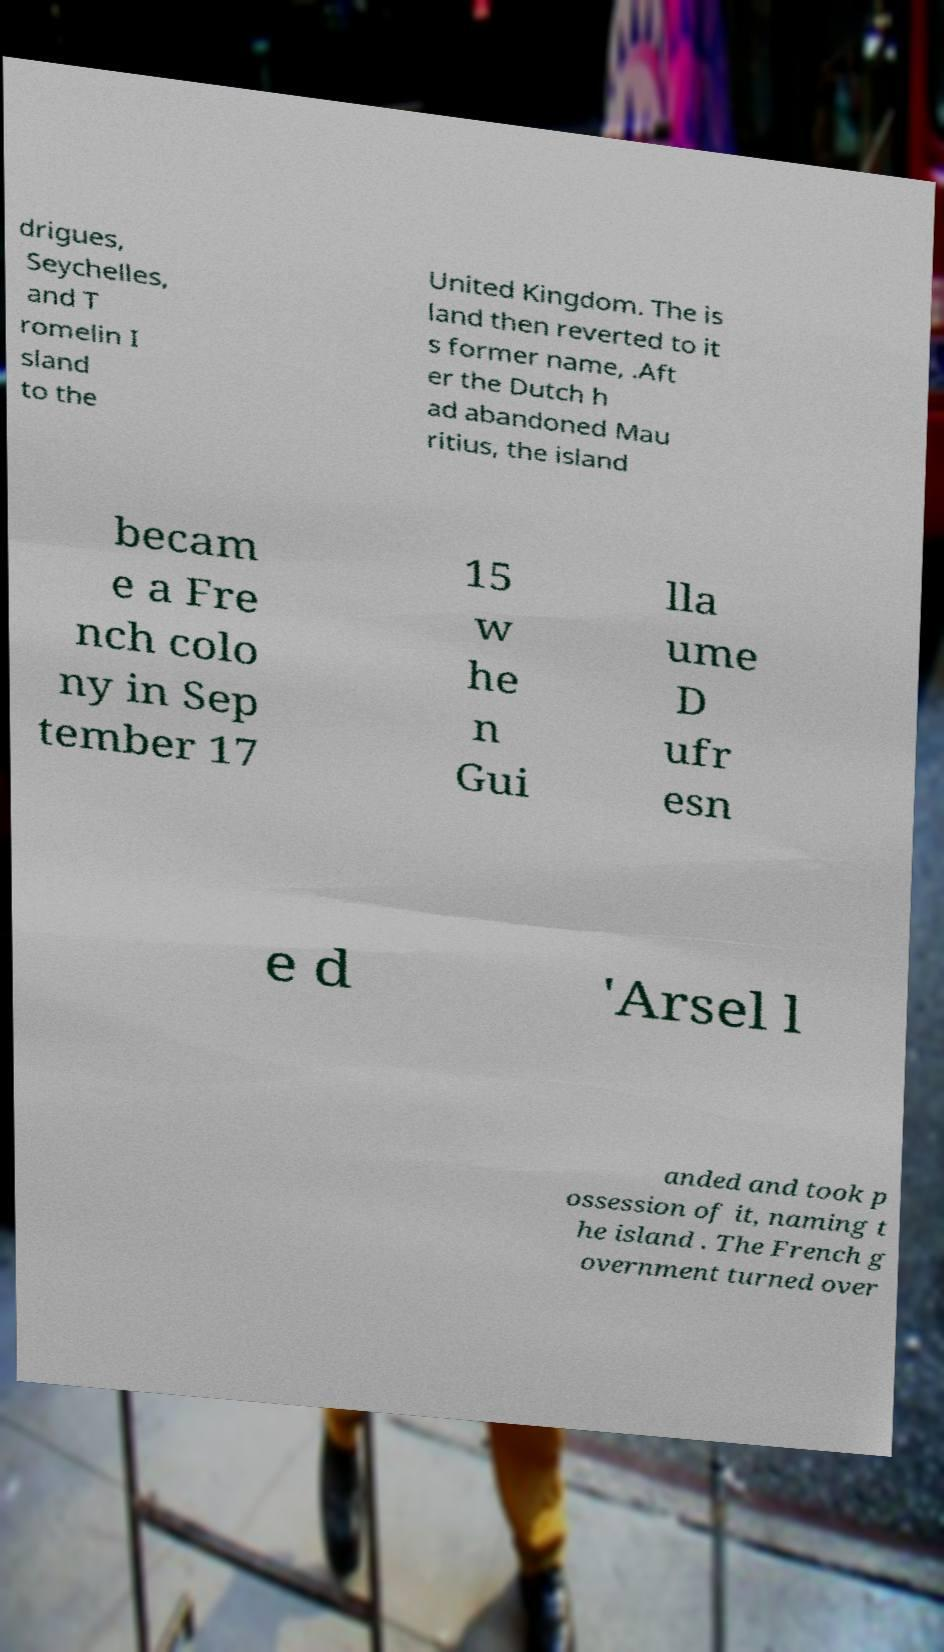I need the written content from this picture converted into text. Can you do that? drigues, Seychelles, and T romelin I sland to the United Kingdom. The is land then reverted to it s former name, .Aft er the Dutch h ad abandoned Mau ritius, the island becam e a Fre nch colo ny in Sep tember 17 15 w he n Gui lla ume D ufr esn e d 'Arsel l anded and took p ossession of it, naming t he island . The French g overnment turned over 